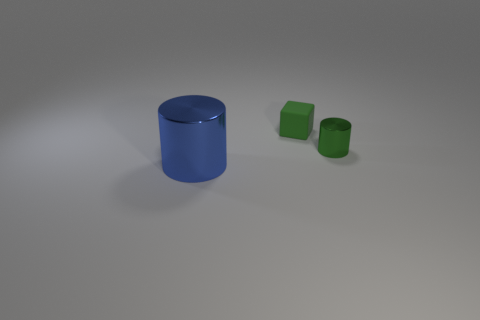Add 2 rubber blocks. How many objects exist? 5 Subtract all cylinders. How many objects are left? 1 Add 2 blue metal cylinders. How many blue metal cylinders are left? 3 Add 2 tiny cylinders. How many tiny cylinders exist? 3 Subtract 0 cyan blocks. How many objects are left? 3 Subtract all blue things. Subtract all green metallic things. How many objects are left? 1 